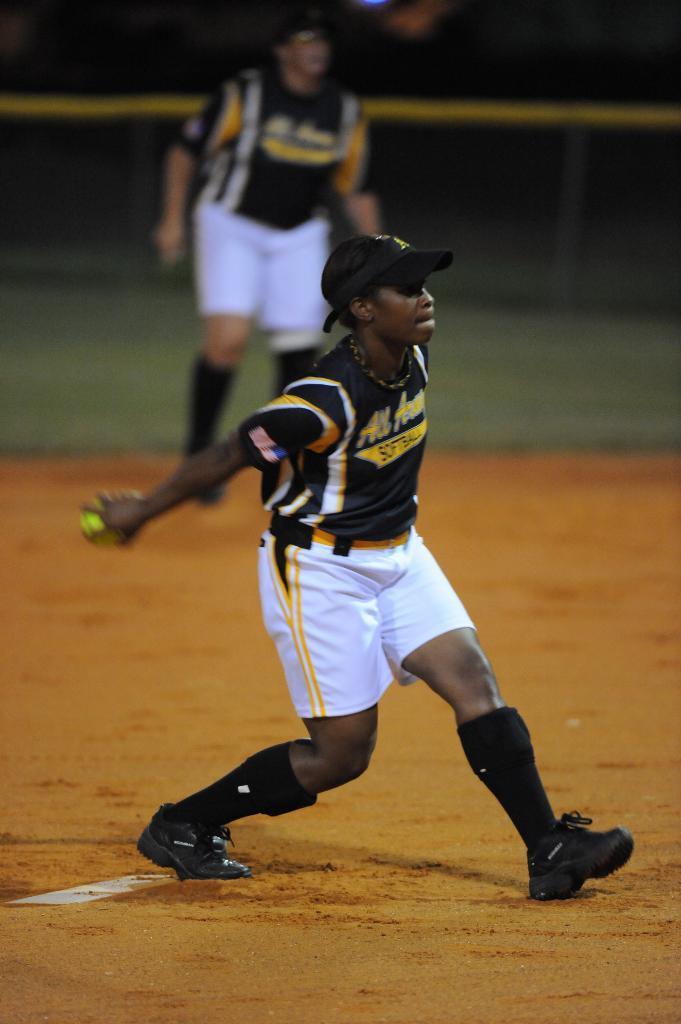In one or two sentences, can you explain what this image depicts? In this picture there is a man who is wearing cap, t-shirt, short and shoe. He is holding a ball. In the back there is another player who is wearing the same dress and standing near to the fencing and grass. 